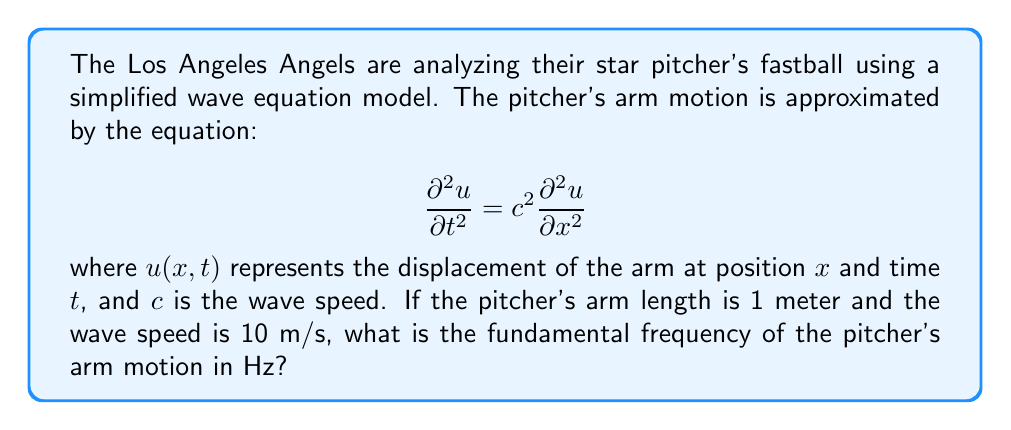Could you help me with this problem? To solve this problem, we need to consider the following steps:

1) The fundamental frequency of a wave is related to the length of the medium (in this case, the pitcher's arm) and the wave speed.

2) For a fixed string (which we can use as an analogy for the pitcher's arm), the fundamental wavelength $\lambda$ is twice the length of the string. In this case:

   $$\lambda = 2L = 2 \cdot 1\text{ m} = 2\text{ m}$$

3) The relationship between wave speed $c$, wavelength $\lambda$, and frequency $f$ is given by:

   $$c = \lambda f$$

4) Rearranging this equation to solve for frequency:

   $$f = \frac{c}{\lambda}$$

5) Substituting the known values:

   $$f = \frac{10\text{ m/s}}{2\text{ m}} = 5\text{ Hz}$$

Therefore, the fundamental frequency of the pitcher's arm motion is 5 Hz.
Answer: 5 Hz 